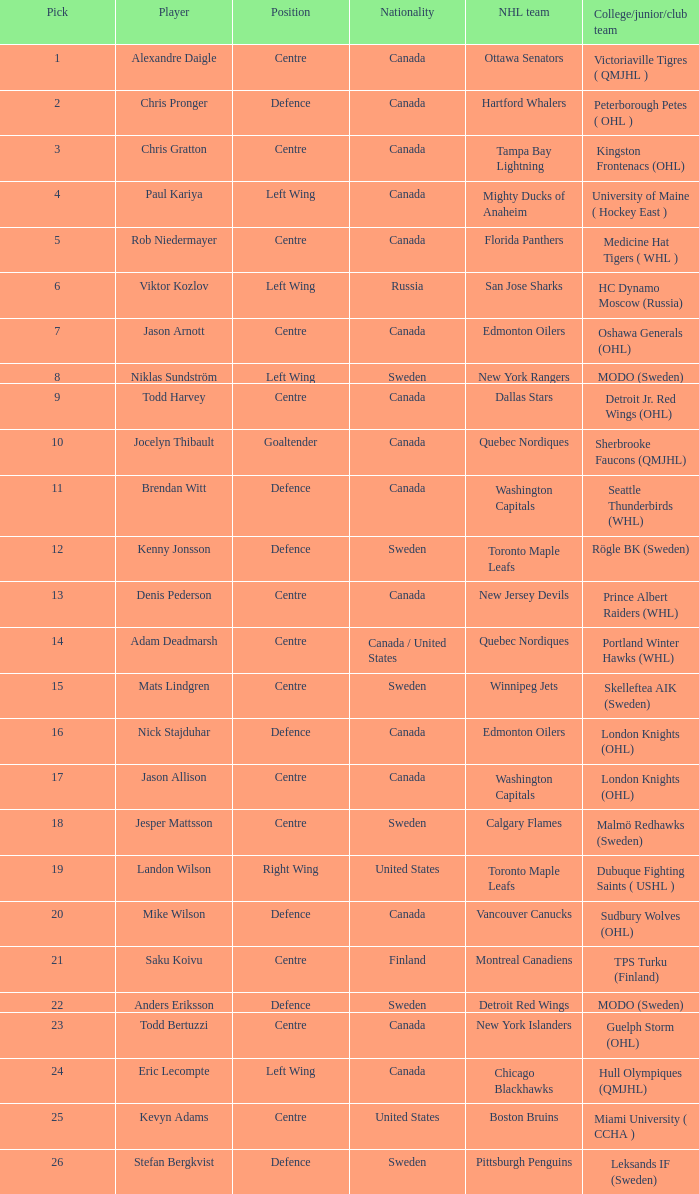What is the college/junior/club team name of player Mats Lindgren? Skelleftea AIK (Sweden). 